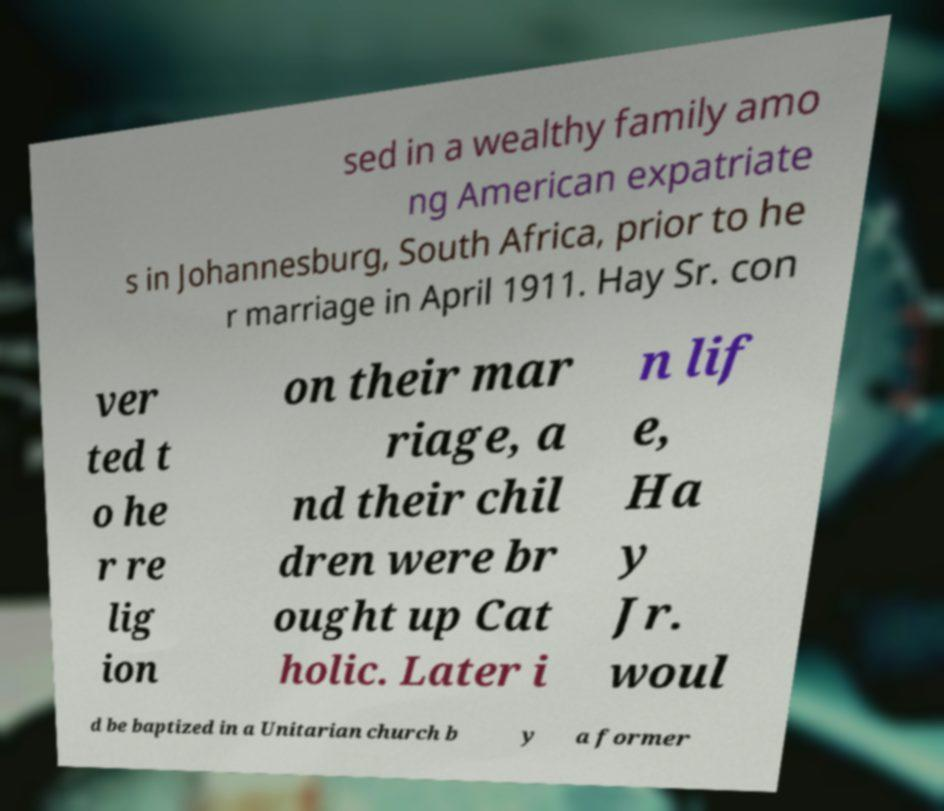There's text embedded in this image that I need extracted. Can you transcribe it verbatim? sed in a wealthy family amo ng American expatriate s in Johannesburg, South Africa, prior to he r marriage in April 1911. Hay Sr. con ver ted t o he r re lig ion on their mar riage, a nd their chil dren were br ought up Cat holic. Later i n lif e, Ha y Jr. woul d be baptized in a Unitarian church b y a former 